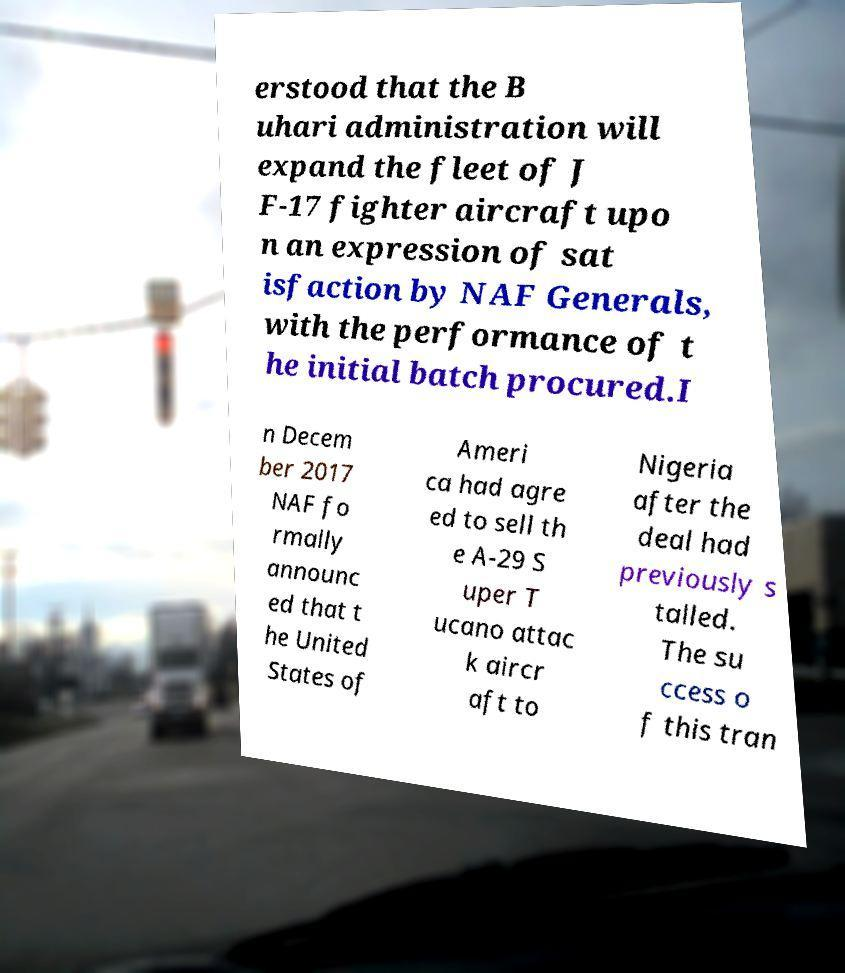For documentation purposes, I need the text within this image transcribed. Could you provide that? erstood that the B uhari administration will expand the fleet of J F-17 fighter aircraft upo n an expression of sat isfaction by NAF Generals, with the performance of t he initial batch procured.I n Decem ber 2017 NAF fo rmally announc ed that t he United States of Ameri ca had agre ed to sell th e A-29 S uper T ucano attac k aircr aft to Nigeria after the deal had previously s talled. The su ccess o f this tran 